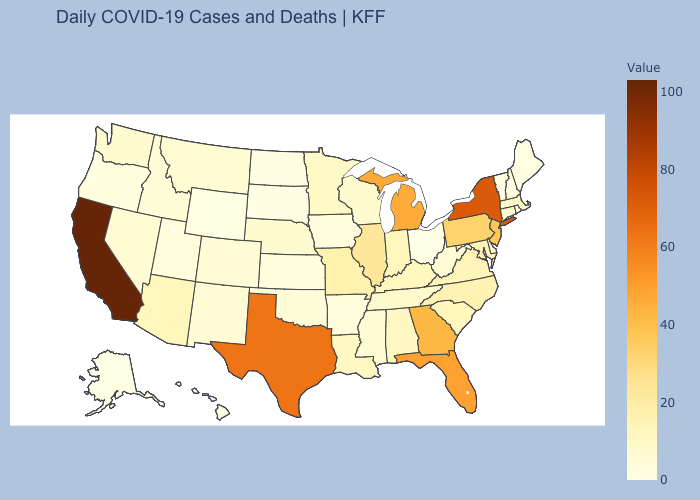Which states have the lowest value in the Northeast?
Be succinct. Rhode Island, Vermont. Which states have the lowest value in the USA?
Concise answer only. Ohio. Does the map have missing data?
Write a very short answer. No. 